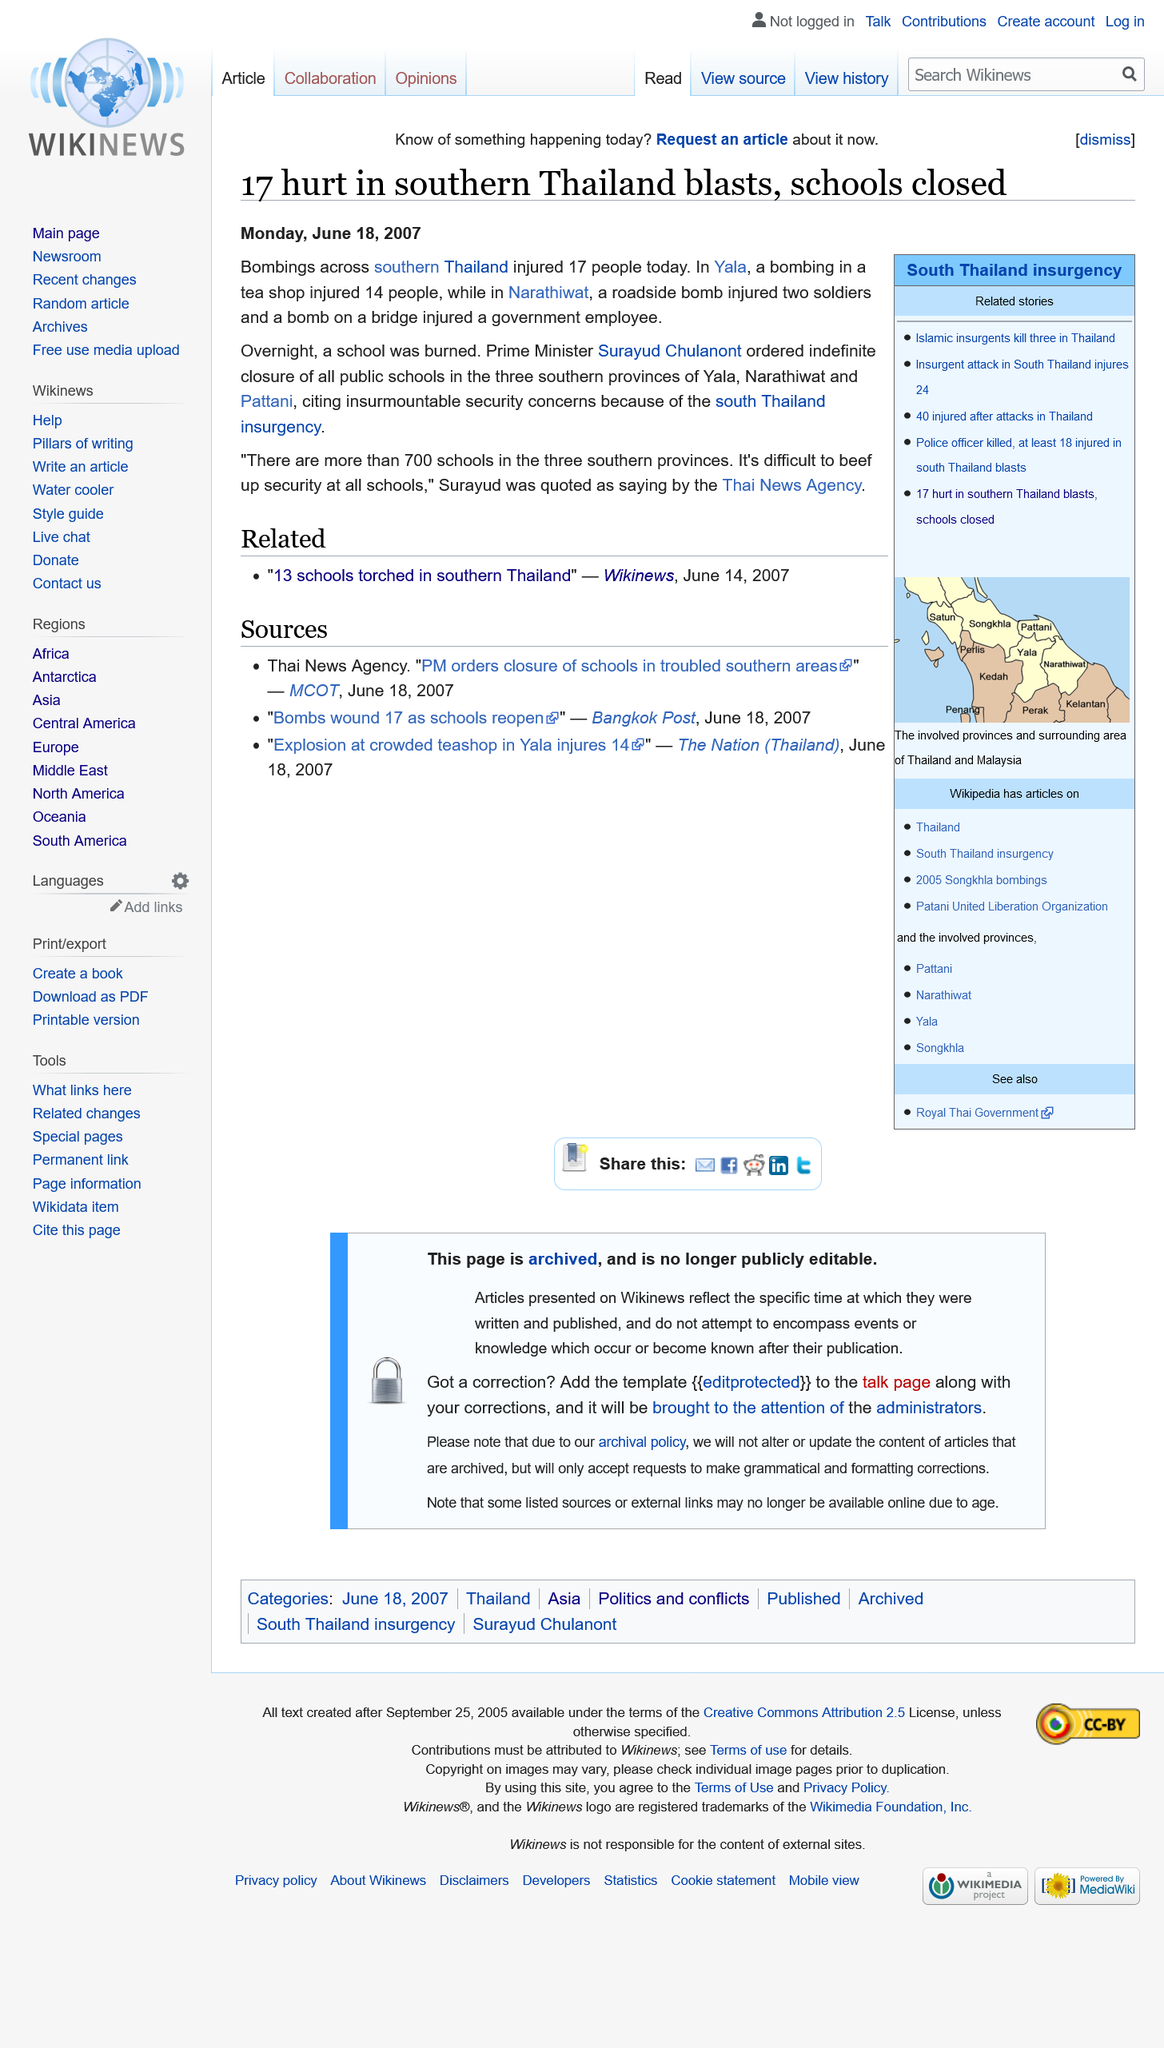List a handful of essential elements in this visual. Seventeen individuals sustained injuries as a result of the bombings across Thailand. As of today, Surayud Chulanont serves as the Prime Minister of Thailand. On June 18, 2007, bombings occurred throughout southern Thailand, causing widespread destruction and loss of life. 